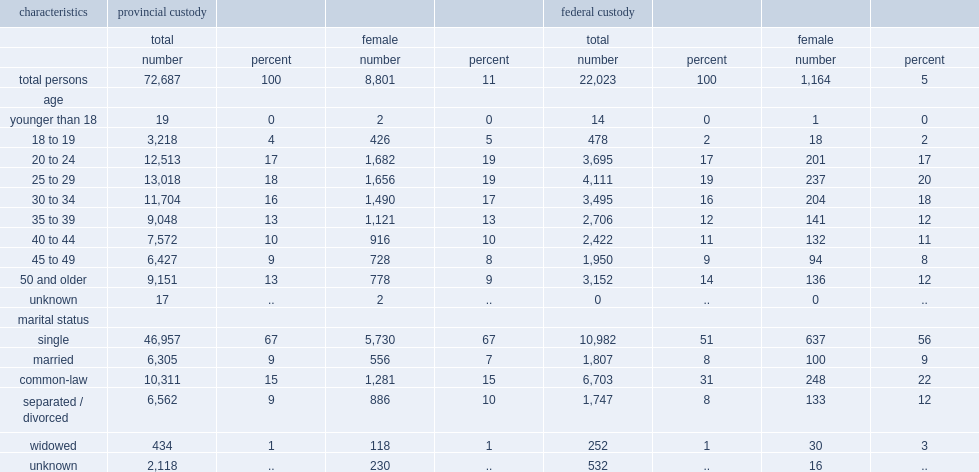In 2014/2015, what was the percentage of women younger than 35 years of age in provincial custody? 60. In 2014/2015, what was the percentage of women younger than 35 years of age in federal custody? 57. Among the overall women involved in provincial and federal correctional custodial services aged over 18 years old in 2014/2015, what was the percentage of those between the ages of 18 and 34? 0.593656. In 2014/2015, what was the percentage of "single, never married" women in provincial custody? 67.0. In 2014/2015, what was the percentage of "single, never married" women in federal custody? 56.0. 